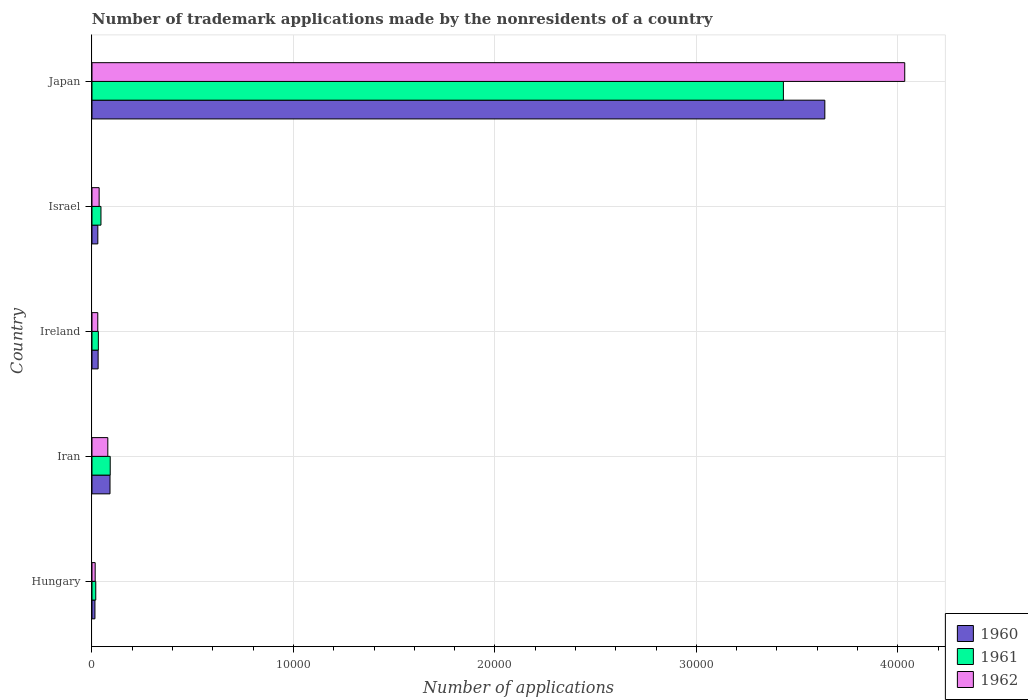How many bars are there on the 4th tick from the bottom?
Ensure brevity in your answer.  3. What is the label of the 4th group of bars from the top?
Your answer should be very brief. Iran. What is the number of trademark applications made by the nonresidents in 1960 in Iran?
Ensure brevity in your answer.  895. Across all countries, what is the maximum number of trademark applications made by the nonresidents in 1962?
Your answer should be compact. 4.03e+04. Across all countries, what is the minimum number of trademark applications made by the nonresidents in 1960?
Give a very brief answer. 147. In which country was the number of trademark applications made by the nonresidents in 1961 maximum?
Provide a short and direct response. Japan. In which country was the number of trademark applications made by the nonresidents in 1960 minimum?
Offer a very short reply. Hungary. What is the total number of trademark applications made by the nonresidents in 1960 in the graph?
Give a very brief answer. 3.80e+04. What is the difference between the number of trademark applications made by the nonresidents in 1962 in Hungary and that in Israel?
Offer a very short reply. -197. What is the difference between the number of trademark applications made by the nonresidents in 1962 in Japan and the number of trademark applications made by the nonresidents in 1960 in Ireland?
Offer a terse response. 4.00e+04. What is the average number of trademark applications made by the nonresidents in 1960 per country?
Your answer should be compact. 7602.8. What is the difference between the number of trademark applications made by the nonresidents in 1961 and number of trademark applications made by the nonresidents in 1960 in Iran?
Keep it short and to the point. 10. In how many countries, is the number of trademark applications made by the nonresidents in 1961 greater than 36000 ?
Ensure brevity in your answer.  0. What is the ratio of the number of trademark applications made by the nonresidents in 1961 in Iran to that in Japan?
Your answer should be compact. 0.03. Is the number of trademark applications made by the nonresidents in 1961 in Israel less than that in Japan?
Offer a very short reply. Yes. What is the difference between the highest and the second highest number of trademark applications made by the nonresidents in 1960?
Your answer should be compact. 3.55e+04. What is the difference between the highest and the lowest number of trademark applications made by the nonresidents in 1962?
Keep it short and to the point. 4.02e+04. Is the sum of the number of trademark applications made by the nonresidents in 1961 in Israel and Japan greater than the maximum number of trademark applications made by the nonresidents in 1962 across all countries?
Ensure brevity in your answer.  No. Is it the case that in every country, the sum of the number of trademark applications made by the nonresidents in 1960 and number of trademark applications made by the nonresidents in 1961 is greater than the number of trademark applications made by the nonresidents in 1962?
Your answer should be very brief. Yes. How many countries are there in the graph?
Make the answer very short. 5. Does the graph contain grids?
Make the answer very short. Yes. How are the legend labels stacked?
Your answer should be compact. Vertical. What is the title of the graph?
Keep it short and to the point. Number of trademark applications made by the nonresidents of a country. Does "2008" appear as one of the legend labels in the graph?
Make the answer very short. No. What is the label or title of the X-axis?
Provide a succinct answer. Number of applications. What is the Number of applications of 1960 in Hungary?
Make the answer very short. 147. What is the Number of applications of 1961 in Hungary?
Your answer should be very brief. 188. What is the Number of applications of 1962 in Hungary?
Offer a very short reply. 158. What is the Number of applications of 1960 in Iran?
Offer a terse response. 895. What is the Number of applications of 1961 in Iran?
Provide a succinct answer. 905. What is the Number of applications of 1962 in Iran?
Offer a terse response. 786. What is the Number of applications of 1960 in Ireland?
Offer a terse response. 305. What is the Number of applications of 1961 in Ireland?
Your answer should be compact. 316. What is the Number of applications in 1962 in Ireland?
Your answer should be very brief. 288. What is the Number of applications of 1960 in Israel?
Provide a short and direct response. 290. What is the Number of applications in 1961 in Israel?
Ensure brevity in your answer.  446. What is the Number of applications of 1962 in Israel?
Your response must be concise. 355. What is the Number of applications of 1960 in Japan?
Your response must be concise. 3.64e+04. What is the Number of applications of 1961 in Japan?
Provide a short and direct response. 3.43e+04. What is the Number of applications in 1962 in Japan?
Offer a very short reply. 4.03e+04. Across all countries, what is the maximum Number of applications in 1960?
Offer a terse response. 3.64e+04. Across all countries, what is the maximum Number of applications of 1961?
Provide a short and direct response. 3.43e+04. Across all countries, what is the maximum Number of applications of 1962?
Provide a short and direct response. 4.03e+04. Across all countries, what is the minimum Number of applications in 1960?
Your answer should be compact. 147. Across all countries, what is the minimum Number of applications in 1961?
Keep it short and to the point. 188. Across all countries, what is the minimum Number of applications in 1962?
Your answer should be very brief. 158. What is the total Number of applications of 1960 in the graph?
Your answer should be compact. 3.80e+04. What is the total Number of applications of 1961 in the graph?
Keep it short and to the point. 3.62e+04. What is the total Number of applications in 1962 in the graph?
Keep it short and to the point. 4.19e+04. What is the difference between the Number of applications of 1960 in Hungary and that in Iran?
Provide a succinct answer. -748. What is the difference between the Number of applications of 1961 in Hungary and that in Iran?
Your answer should be compact. -717. What is the difference between the Number of applications of 1962 in Hungary and that in Iran?
Provide a succinct answer. -628. What is the difference between the Number of applications of 1960 in Hungary and that in Ireland?
Provide a short and direct response. -158. What is the difference between the Number of applications of 1961 in Hungary and that in Ireland?
Provide a short and direct response. -128. What is the difference between the Number of applications in 1962 in Hungary and that in Ireland?
Offer a terse response. -130. What is the difference between the Number of applications in 1960 in Hungary and that in Israel?
Keep it short and to the point. -143. What is the difference between the Number of applications in 1961 in Hungary and that in Israel?
Give a very brief answer. -258. What is the difference between the Number of applications of 1962 in Hungary and that in Israel?
Provide a short and direct response. -197. What is the difference between the Number of applications of 1960 in Hungary and that in Japan?
Give a very brief answer. -3.62e+04. What is the difference between the Number of applications of 1961 in Hungary and that in Japan?
Your answer should be compact. -3.41e+04. What is the difference between the Number of applications in 1962 in Hungary and that in Japan?
Your response must be concise. -4.02e+04. What is the difference between the Number of applications of 1960 in Iran and that in Ireland?
Ensure brevity in your answer.  590. What is the difference between the Number of applications of 1961 in Iran and that in Ireland?
Provide a succinct answer. 589. What is the difference between the Number of applications of 1962 in Iran and that in Ireland?
Provide a short and direct response. 498. What is the difference between the Number of applications in 1960 in Iran and that in Israel?
Give a very brief answer. 605. What is the difference between the Number of applications of 1961 in Iran and that in Israel?
Offer a terse response. 459. What is the difference between the Number of applications of 1962 in Iran and that in Israel?
Your answer should be compact. 431. What is the difference between the Number of applications of 1960 in Iran and that in Japan?
Offer a very short reply. -3.55e+04. What is the difference between the Number of applications of 1961 in Iran and that in Japan?
Ensure brevity in your answer.  -3.34e+04. What is the difference between the Number of applications in 1962 in Iran and that in Japan?
Provide a succinct answer. -3.96e+04. What is the difference between the Number of applications of 1960 in Ireland and that in Israel?
Your answer should be very brief. 15. What is the difference between the Number of applications in 1961 in Ireland and that in Israel?
Your answer should be compact. -130. What is the difference between the Number of applications in 1962 in Ireland and that in Israel?
Your answer should be very brief. -67. What is the difference between the Number of applications in 1960 in Ireland and that in Japan?
Keep it short and to the point. -3.61e+04. What is the difference between the Number of applications in 1961 in Ireland and that in Japan?
Make the answer very short. -3.40e+04. What is the difference between the Number of applications in 1962 in Ireland and that in Japan?
Offer a very short reply. -4.01e+04. What is the difference between the Number of applications of 1960 in Israel and that in Japan?
Give a very brief answer. -3.61e+04. What is the difference between the Number of applications in 1961 in Israel and that in Japan?
Make the answer very short. -3.39e+04. What is the difference between the Number of applications in 1962 in Israel and that in Japan?
Offer a very short reply. -4.00e+04. What is the difference between the Number of applications of 1960 in Hungary and the Number of applications of 1961 in Iran?
Give a very brief answer. -758. What is the difference between the Number of applications of 1960 in Hungary and the Number of applications of 1962 in Iran?
Offer a very short reply. -639. What is the difference between the Number of applications of 1961 in Hungary and the Number of applications of 1962 in Iran?
Offer a very short reply. -598. What is the difference between the Number of applications of 1960 in Hungary and the Number of applications of 1961 in Ireland?
Offer a terse response. -169. What is the difference between the Number of applications of 1960 in Hungary and the Number of applications of 1962 in Ireland?
Your answer should be very brief. -141. What is the difference between the Number of applications in 1961 in Hungary and the Number of applications in 1962 in Ireland?
Your answer should be compact. -100. What is the difference between the Number of applications of 1960 in Hungary and the Number of applications of 1961 in Israel?
Provide a short and direct response. -299. What is the difference between the Number of applications in 1960 in Hungary and the Number of applications in 1962 in Israel?
Your answer should be very brief. -208. What is the difference between the Number of applications in 1961 in Hungary and the Number of applications in 1962 in Israel?
Your answer should be very brief. -167. What is the difference between the Number of applications of 1960 in Hungary and the Number of applications of 1961 in Japan?
Provide a succinct answer. -3.42e+04. What is the difference between the Number of applications in 1960 in Hungary and the Number of applications in 1962 in Japan?
Provide a succinct answer. -4.02e+04. What is the difference between the Number of applications of 1961 in Hungary and the Number of applications of 1962 in Japan?
Make the answer very short. -4.02e+04. What is the difference between the Number of applications in 1960 in Iran and the Number of applications in 1961 in Ireland?
Offer a very short reply. 579. What is the difference between the Number of applications in 1960 in Iran and the Number of applications in 1962 in Ireland?
Your response must be concise. 607. What is the difference between the Number of applications of 1961 in Iran and the Number of applications of 1962 in Ireland?
Make the answer very short. 617. What is the difference between the Number of applications of 1960 in Iran and the Number of applications of 1961 in Israel?
Your answer should be very brief. 449. What is the difference between the Number of applications in 1960 in Iran and the Number of applications in 1962 in Israel?
Make the answer very short. 540. What is the difference between the Number of applications of 1961 in Iran and the Number of applications of 1962 in Israel?
Ensure brevity in your answer.  550. What is the difference between the Number of applications of 1960 in Iran and the Number of applications of 1961 in Japan?
Ensure brevity in your answer.  -3.34e+04. What is the difference between the Number of applications in 1960 in Iran and the Number of applications in 1962 in Japan?
Your answer should be compact. -3.94e+04. What is the difference between the Number of applications in 1961 in Iran and the Number of applications in 1962 in Japan?
Your answer should be very brief. -3.94e+04. What is the difference between the Number of applications in 1960 in Ireland and the Number of applications in 1961 in Israel?
Offer a very short reply. -141. What is the difference between the Number of applications in 1960 in Ireland and the Number of applications in 1962 in Israel?
Your answer should be very brief. -50. What is the difference between the Number of applications in 1961 in Ireland and the Number of applications in 1962 in Israel?
Provide a short and direct response. -39. What is the difference between the Number of applications of 1960 in Ireland and the Number of applications of 1961 in Japan?
Ensure brevity in your answer.  -3.40e+04. What is the difference between the Number of applications of 1960 in Ireland and the Number of applications of 1962 in Japan?
Offer a terse response. -4.00e+04. What is the difference between the Number of applications in 1961 in Ireland and the Number of applications in 1962 in Japan?
Make the answer very short. -4.00e+04. What is the difference between the Number of applications in 1960 in Israel and the Number of applications in 1961 in Japan?
Offer a terse response. -3.40e+04. What is the difference between the Number of applications in 1960 in Israel and the Number of applications in 1962 in Japan?
Offer a terse response. -4.01e+04. What is the difference between the Number of applications of 1961 in Israel and the Number of applications of 1962 in Japan?
Give a very brief answer. -3.99e+04. What is the average Number of applications of 1960 per country?
Offer a terse response. 7602.8. What is the average Number of applications in 1961 per country?
Provide a succinct answer. 7235. What is the average Number of applications in 1962 per country?
Make the answer very short. 8386. What is the difference between the Number of applications of 1960 and Number of applications of 1961 in Hungary?
Ensure brevity in your answer.  -41. What is the difference between the Number of applications of 1960 and Number of applications of 1962 in Iran?
Keep it short and to the point. 109. What is the difference between the Number of applications in 1961 and Number of applications in 1962 in Iran?
Your answer should be compact. 119. What is the difference between the Number of applications in 1960 and Number of applications in 1962 in Ireland?
Provide a succinct answer. 17. What is the difference between the Number of applications of 1961 and Number of applications of 1962 in Ireland?
Give a very brief answer. 28. What is the difference between the Number of applications in 1960 and Number of applications in 1961 in Israel?
Ensure brevity in your answer.  -156. What is the difference between the Number of applications in 1960 and Number of applications in 1962 in Israel?
Offer a very short reply. -65. What is the difference between the Number of applications of 1961 and Number of applications of 1962 in Israel?
Your answer should be very brief. 91. What is the difference between the Number of applications in 1960 and Number of applications in 1961 in Japan?
Make the answer very short. 2057. What is the difference between the Number of applications in 1960 and Number of applications in 1962 in Japan?
Your response must be concise. -3966. What is the difference between the Number of applications in 1961 and Number of applications in 1962 in Japan?
Offer a very short reply. -6023. What is the ratio of the Number of applications of 1960 in Hungary to that in Iran?
Offer a terse response. 0.16. What is the ratio of the Number of applications of 1961 in Hungary to that in Iran?
Your answer should be compact. 0.21. What is the ratio of the Number of applications in 1962 in Hungary to that in Iran?
Give a very brief answer. 0.2. What is the ratio of the Number of applications of 1960 in Hungary to that in Ireland?
Keep it short and to the point. 0.48. What is the ratio of the Number of applications of 1961 in Hungary to that in Ireland?
Provide a succinct answer. 0.59. What is the ratio of the Number of applications of 1962 in Hungary to that in Ireland?
Provide a succinct answer. 0.55. What is the ratio of the Number of applications of 1960 in Hungary to that in Israel?
Offer a terse response. 0.51. What is the ratio of the Number of applications of 1961 in Hungary to that in Israel?
Give a very brief answer. 0.42. What is the ratio of the Number of applications in 1962 in Hungary to that in Israel?
Provide a short and direct response. 0.45. What is the ratio of the Number of applications in 1960 in Hungary to that in Japan?
Make the answer very short. 0. What is the ratio of the Number of applications in 1961 in Hungary to that in Japan?
Your answer should be compact. 0.01. What is the ratio of the Number of applications in 1962 in Hungary to that in Japan?
Offer a terse response. 0. What is the ratio of the Number of applications in 1960 in Iran to that in Ireland?
Provide a succinct answer. 2.93. What is the ratio of the Number of applications of 1961 in Iran to that in Ireland?
Keep it short and to the point. 2.86. What is the ratio of the Number of applications in 1962 in Iran to that in Ireland?
Keep it short and to the point. 2.73. What is the ratio of the Number of applications of 1960 in Iran to that in Israel?
Keep it short and to the point. 3.09. What is the ratio of the Number of applications in 1961 in Iran to that in Israel?
Provide a succinct answer. 2.03. What is the ratio of the Number of applications of 1962 in Iran to that in Israel?
Give a very brief answer. 2.21. What is the ratio of the Number of applications of 1960 in Iran to that in Japan?
Make the answer very short. 0.02. What is the ratio of the Number of applications in 1961 in Iran to that in Japan?
Provide a succinct answer. 0.03. What is the ratio of the Number of applications in 1962 in Iran to that in Japan?
Give a very brief answer. 0.02. What is the ratio of the Number of applications of 1960 in Ireland to that in Israel?
Provide a succinct answer. 1.05. What is the ratio of the Number of applications in 1961 in Ireland to that in Israel?
Give a very brief answer. 0.71. What is the ratio of the Number of applications of 1962 in Ireland to that in Israel?
Offer a very short reply. 0.81. What is the ratio of the Number of applications in 1960 in Ireland to that in Japan?
Your answer should be very brief. 0.01. What is the ratio of the Number of applications in 1961 in Ireland to that in Japan?
Give a very brief answer. 0.01. What is the ratio of the Number of applications in 1962 in Ireland to that in Japan?
Offer a terse response. 0.01. What is the ratio of the Number of applications in 1960 in Israel to that in Japan?
Ensure brevity in your answer.  0.01. What is the ratio of the Number of applications of 1961 in Israel to that in Japan?
Keep it short and to the point. 0.01. What is the ratio of the Number of applications in 1962 in Israel to that in Japan?
Your response must be concise. 0.01. What is the difference between the highest and the second highest Number of applications in 1960?
Give a very brief answer. 3.55e+04. What is the difference between the highest and the second highest Number of applications in 1961?
Your answer should be very brief. 3.34e+04. What is the difference between the highest and the second highest Number of applications of 1962?
Make the answer very short. 3.96e+04. What is the difference between the highest and the lowest Number of applications of 1960?
Offer a terse response. 3.62e+04. What is the difference between the highest and the lowest Number of applications of 1961?
Offer a very short reply. 3.41e+04. What is the difference between the highest and the lowest Number of applications in 1962?
Offer a terse response. 4.02e+04. 